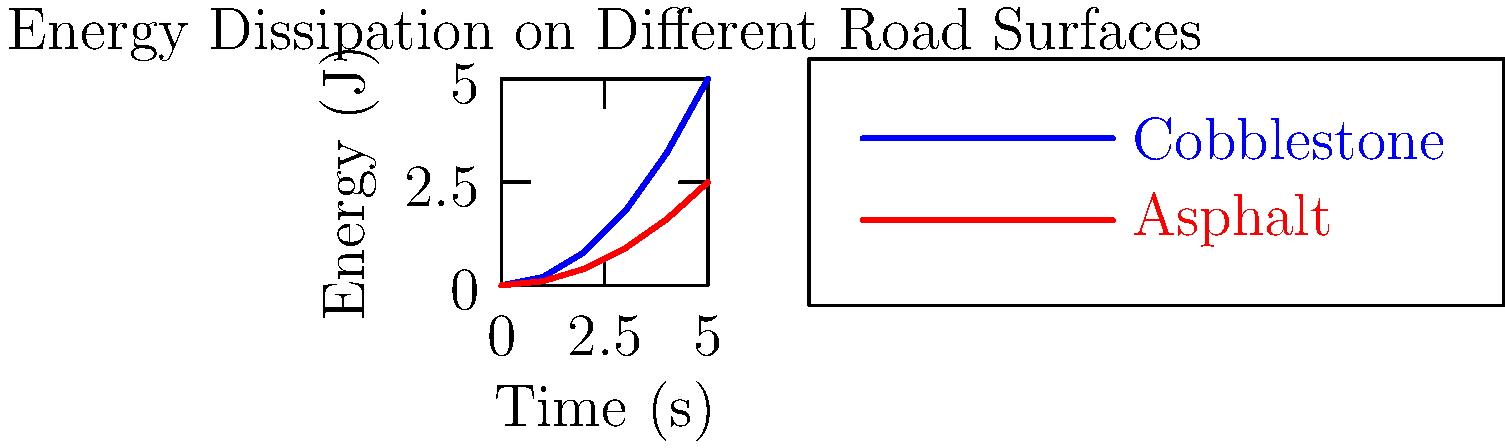As a local entrepreneur in the Northern Netherlands, you're considering starting a bicycle tour company. You notice that riding on cobblestone streets, common in historic Dutch towns, feels different from riding on smooth asphalt. The graph shows the energy dissipation over time for a bicycle ridden at constant speed on cobblestone and asphalt surfaces. After 5 seconds, how much more energy (in Joules) is dissipated on the cobblestone surface compared to the asphalt surface? To solve this problem, we need to follow these steps:

1. Identify the energy dissipated on each surface after 5 seconds:
   - For cobblestone (blue line): $E_{cobblestone} = 5$ J
   - For asphalt (red line): $E_{asphalt} = 2.5$ J

2. Calculate the difference in energy dissipation:
   $\Delta E = E_{cobblestone} - E_{asphalt}$
   $\Delta E = 5 \text{ J} - 2.5 \text{ J} = 2.5 \text{ J}$

The difference in energy dissipation between the cobblestone and asphalt surfaces after 5 seconds is 2.5 Joules.

This higher energy dissipation on cobblestone is due to increased vibrations and deformations of the bicycle and rider, as well as greater rolling resistance. This information is crucial for planning tour routes and estimating energy expenditure for cyclists in your potential business.
Answer: 2.5 J 